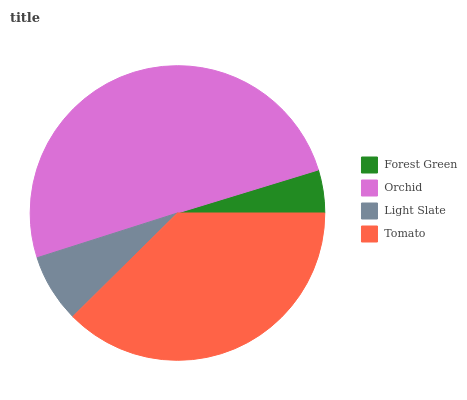Is Forest Green the minimum?
Answer yes or no. Yes. Is Orchid the maximum?
Answer yes or no. Yes. Is Light Slate the minimum?
Answer yes or no. No. Is Light Slate the maximum?
Answer yes or no. No. Is Orchid greater than Light Slate?
Answer yes or no. Yes. Is Light Slate less than Orchid?
Answer yes or no. Yes. Is Light Slate greater than Orchid?
Answer yes or no. No. Is Orchid less than Light Slate?
Answer yes or no. No. Is Tomato the high median?
Answer yes or no. Yes. Is Light Slate the low median?
Answer yes or no. Yes. Is Forest Green the high median?
Answer yes or no. No. Is Tomato the low median?
Answer yes or no. No. 